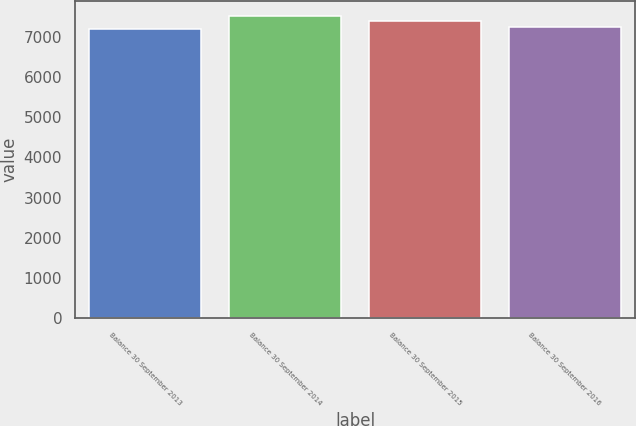Convert chart to OTSL. <chart><loc_0><loc_0><loc_500><loc_500><bar_chart><fcel>Balance 30 September 2013<fcel>Balance 30 September 2014<fcel>Balance 30 September 2015<fcel>Balance 30 September 2016<nl><fcel>7198.9<fcel>7521.4<fcel>7381.1<fcel>7231.15<nl></chart> 